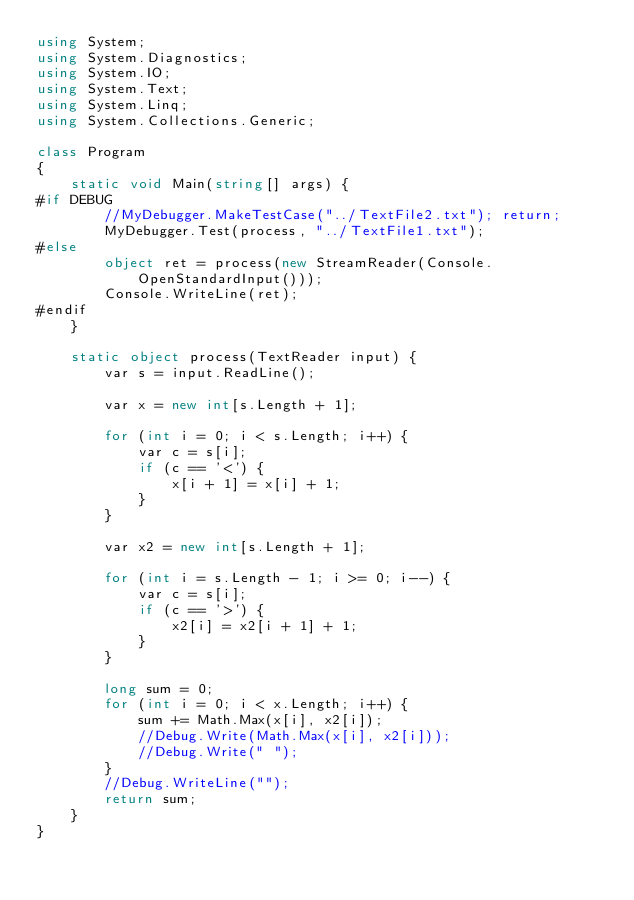Convert code to text. <code><loc_0><loc_0><loc_500><loc_500><_C#_>using System;
using System.Diagnostics;
using System.IO;
using System.Text;
using System.Linq;
using System.Collections.Generic;

class Program
{
    static void Main(string[] args) {
#if DEBUG
        //MyDebugger.MakeTestCase("../TextFile2.txt"); return;
        MyDebugger.Test(process, "../TextFile1.txt");
#else
        object ret = process(new StreamReader(Console.OpenStandardInput()));
        Console.WriteLine(ret);
#endif
    }

    static object process(TextReader input) {
        var s = input.ReadLine();

        var x = new int[s.Length + 1];

        for (int i = 0; i < s.Length; i++) {
            var c = s[i];
            if (c == '<') {
                x[i + 1] = x[i] + 1;
            }
        }

        var x2 = new int[s.Length + 1];

        for (int i = s.Length - 1; i >= 0; i--) {
            var c = s[i];
            if (c == '>') {
                x2[i] = x2[i + 1] + 1;
            }
        }

        long sum = 0;
        for (int i = 0; i < x.Length; i++) {
            sum += Math.Max(x[i], x2[i]);
            //Debug.Write(Math.Max(x[i], x2[i]));
            //Debug.Write(" ");
        }
        //Debug.WriteLine("");
        return sum;
    }
}
</code> 